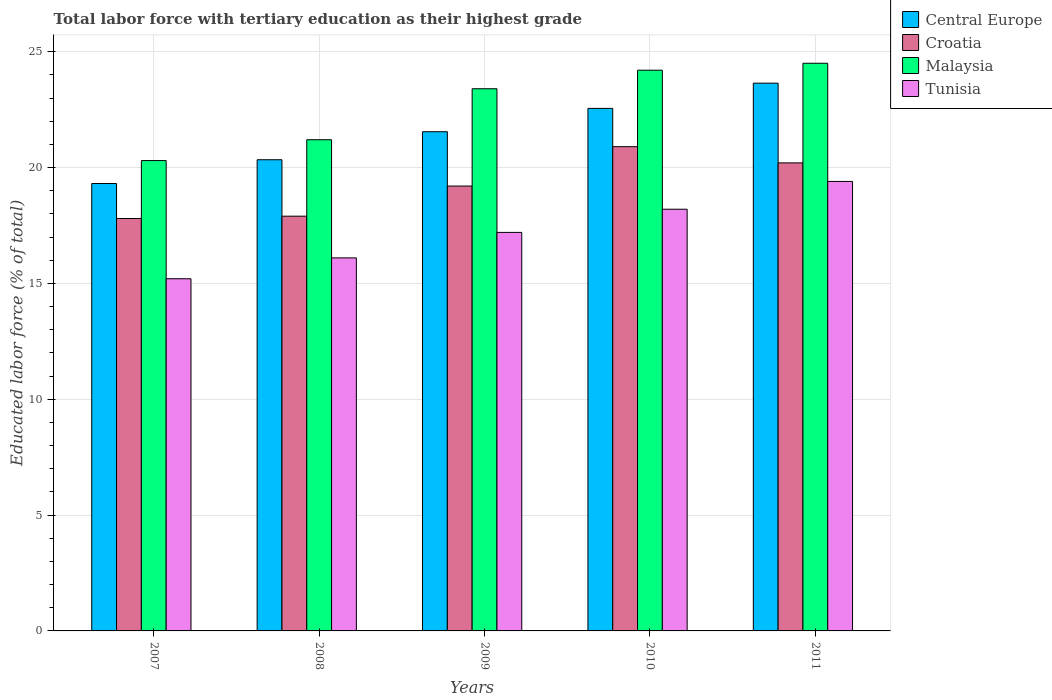How many different coloured bars are there?
Provide a succinct answer. 4. What is the label of the 1st group of bars from the left?
Provide a short and direct response. 2007. In how many cases, is the number of bars for a given year not equal to the number of legend labels?
Keep it short and to the point. 0. What is the percentage of male labor force with tertiary education in Central Europe in 2007?
Keep it short and to the point. 19.31. Across all years, what is the maximum percentage of male labor force with tertiary education in Tunisia?
Make the answer very short. 19.4. Across all years, what is the minimum percentage of male labor force with tertiary education in Croatia?
Give a very brief answer. 17.8. In which year was the percentage of male labor force with tertiary education in Malaysia maximum?
Your answer should be very brief. 2011. What is the total percentage of male labor force with tertiary education in Malaysia in the graph?
Make the answer very short. 113.6. What is the difference between the percentage of male labor force with tertiary education in Croatia in 2007 and that in 2008?
Your response must be concise. -0.1. What is the difference between the percentage of male labor force with tertiary education in Croatia in 2008 and the percentage of male labor force with tertiary education in Central Europe in 2011?
Make the answer very short. -5.74. What is the average percentage of male labor force with tertiary education in Tunisia per year?
Offer a very short reply. 17.22. In the year 2009, what is the difference between the percentage of male labor force with tertiary education in Tunisia and percentage of male labor force with tertiary education in Central Europe?
Keep it short and to the point. -4.35. What is the ratio of the percentage of male labor force with tertiary education in Tunisia in 2007 to that in 2010?
Your answer should be compact. 0.84. Is the difference between the percentage of male labor force with tertiary education in Tunisia in 2009 and 2011 greater than the difference between the percentage of male labor force with tertiary education in Central Europe in 2009 and 2011?
Ensure brevity in your answer.  No. What is the difference between the highest and the second highest percentage of male labor force with tertiary education in Croatia?
Ensure brevity in your answer.  0.7. What is the difference between the highest and the lowest percentage of male labor force with tertiary education in Central Europe?
Give a very brief answer. 4.33. In how many years, is the percentage of male labor force with tertiary education in Tunisia greater than the average percentage of male labor force with tertiary education in Tunisia taken over all years?
Keep it short and to the point. 2. What does the 3rd bar from the left in 2008 represents?
Provide a succinct answer. Malaysia. What does the 4th bar from the right in 2009 represents?
Your answer should be compact. Central Europe. How many bars are there?
Offer a terse response. 20. Are all the bars in the graph horizontal?
Offer a very short reply. No. Are the values on the major ticks of Y-axis written in scientific E-notation?
Provide a succinct answer. No. Where does the legend appear in the graph?
Provide a succinct answer. Top right. How many legend labels are there?
Offer a very short reply. 4. What is the title of the graph?
Make the answer very short. Total labor force with tertiary education as their highest grade. Does "Namibia" appear as one of the legend labels in the graph?
Your response must be concise. No. What is the label or title of the Y-axis?
Provide a short and direct response. Educated labor force (% of total). What is the Educated labor force (% of total) of Central Europe in 2007?
Give a very brief answer. 19.31. What is the Educated labor force (% of total) in Croatia in 2007?
Offer a terse response. 17.8. What is the Educated labor force (% of total) of Malaysia in 2007?
Give a very brief answer. 20.3. What is the Educated labor force (% of total) of Tunisia in 2007?
Make the answer very short. 15.2. What is the Educated labor force (% of total) of Central Europe in 2008?
Your answer should be compact. 20.34. What is the Educated labor force (% of total) of Croatia in 2008?
Give a very brief answer. 17.9. What is the Educated labor force (% of total) of Malaysia in 2008?
Keep it short and to the point. 21.2. What is the Educated labor force (% of total) of Tunisia in 2008?
Your answer should be very brief. 16.1. What is the Educated labor force (% of total) in Central Europe in 2009?
Offer a very short reply. 21.55. What is the Educated labor force (% of total) of Croatia in 2009?
Your response must be concise. 19.2. What is the Educated labor force (% of total) in Malaysia in 2009?
Your response must be concise. 23.4. What is the Educated labor force (% of total) of Tunisia in 2009?
Offer a terse response. 17.2. What is the Educated labor force (% of total) of Central Europe in 2010?
Provide a succinct answer. 22.55. What is the Educated labor force (% of total) of Croatia in 2010?
Make the answer very short. 20.9. What is the Educated labor force (% of total) of Malaysia in 2010?
Your response must be concise. 24.2. What is the Educated labor force (% of total) in Tunisia in 2010?
Your answer should be very brief. 18.2. What is the Educated labor force (% of total) in Central Europe in 2011?
Ensure brevity in your answer.  23.64. What is the Educated labor force (% of total) of Croatia in 2011?
Your answer should be very brief. 20.2. What is the Educated labor force (% of total) of Malaysia in 2011?
Make the answer very short. 24.5. What is the Educated labor force (% of total) of Tunisia in 2011?
Provide a short and direct response. 19.4. Across all years, what is the maximum Educated labor force (% of total) in Central Europe?
Offer a terse response. 23.64. Across all years, what is the maximum Educated labor force (% of total) in Croatia?
Ensure brevity in your answer.  20.9. Across all years, what is the maximum Educated labor force (% of total) of Tunisia?
Offer a terse response. 19.4. Across all years, what is the minimum Educated labor force (% of total) of Central Europe?
Keep it short and to the point. 19.31. Across all years, what is the minimum Educated labor force (% of total) of Croatia?
Make the answer very short. 17.8. Across all years, what is the minimum Educated labor force (% of total) of Malaysia?
Ensure brevity in your answer.  20.3. Across all years, what is the minimum Educated labor force (% of total) of Tunisia?
Ensure brevity in your answer.  15.2. What is the total Educated labor force (% of total) of Central Europe in the graph?
Offer a very short reply. 107.38. What is the total Educated labor force (% of total) in Croatia in the graph?
Your answer should be compact. 96. What is the total Educated labor force (% of total) of Malaysia in the graph?
Your answer should be very brief. 113.6. What is the total Educated labor force (% of total) in Tunisia in the graph?
Offer a very short reply. 86.1. What is the difference between the Educated labor force (% of total) in Central Europe in 2007 and that in 2008?
Ensure brevity in your answer.  -1.03. What is the difference between the Educated labor force (% of total) in Croatia in 2007 and that in 2008?
Provide a succinct answer. -0.1. What is the difference between the Educated labor force (% of total) in Tunisia in 2007 and that in 2008?
Give a very brief answer. -0.9. What is the difference between the Educated labor force (% of total) of Central Europe in 2007 and that in 2009?
Ensure brevity in your answer.  -2.23. What is the difference between the Educated labor force (% of total) of Tunisia in 2007 and that in 2009?
Give a very brief answer. -2. What is the difference between the Educated labor force (% of total) in Central Europe in 2007 and that in 2010?
Offer a terse response. -3.24. What is the difference between the Educated labor force (% of total) in Malaysia in 2007 and that in 2010?
Keep it short and to the point. -3.9. What is the difference between the Educated labor force (% of total) of Tunisia in 2007 and that in 2010?
Provide a succinct answer. -3. What is the difference between the Educated labor force (% of total) in Central Europe in 2007 and that in 2011?
Offer a terse response. -4.33. What is the difference between the Educated labor force (% of total) of Tunisia in 2007 and that in 2011?
Make the answer very short. -4.2. What is the difference between the Educated labor force (% of total) of Central Europe in 2008 and that in 2009?
Keep it short and to the point. -1.21. What is the difference between the Educated labor force (% of total) of Central Europe in 2008 and that in 2010?
Give a very brief answer. -2.22. What is the difference between the Educated labor force (% of total) in Croatia in 2008 and that in 2010?
Your answer should be compact. -3. What is the difference between the Educated labor force (% of total) of Malaysia in 2008 and that in 2010?
Offer a terse response. -3. What is the difference between the Educated labor force (% of total) in Tunisia in 2008 and that in 2010?
Provide a short and direct response. -2.1. What is the difference between the Educated labor force (% of total) of Central Europe in 2008 and that in 2011?
Keep it short and to the point. -3.3. What is the difference between the Educated labor force (% of total) in Malaysia in 2008 and that in 2011?
Offer a terse response. -3.3. What is the difference between the Educated labor force (% of total) of Central Europe in 2009 and that in 2010?
Offer a terse response. -1.01. What is the difference between the Educated labor force (% of total) of Croatia in 2009 and that in 2010?
Your answer should be very brief. -1.7. What is the difference between the Educated labor force (% of total) of Malaysia in 2009 and that in 2010?
Give a very brief answer. -0.8. What is the difference between the Educated labor force (% of total) in Central Europe in 2009 and that in 2011?
Your answer should be very brief. -2.1. What is the difference between the Educated labor force (% of total) in Croatia in 2009 and that in 2011?
Ensure brevity in your answer.  -1. What is the difference between the Educated labor force (% of total) in Central Europe in 2010 and that in 2011?
Make the answer very short. -1.09. What is the difference between the Educated labor force (% of total) in Croatia in 2010 and that in 2011?
Your response must be concise. 0.7. What is the difference between the Educated labor force (% of total) in Malaysia in 2010 and that in 2011?
Ensure brevity in your answer.  -0.3. What is the difference between the Educated labor force (% of total) in Central Europe in 2007 and the Educated labor force (% of total) in Croatia in 2008?
Ensure brevity in your answer.  1.41. What is the difference between the Educated labor force (% of total) in Central Europe in 2007 and the Educated labor force (% of total) in Malaysia in 2008?
Your response must be concise. -1.89. What is the difference between the Educated labor force (% of total) in Central Europe in 2007 and the Educated labor force (% of total) in Tunisia in 2008?
Offer a terse response. 3.21. What is the difference between the Educated labor force (% of total) in Croatia in 2007 and the Educated labor force (% of total) in Tunisia in 2008?
Give a very brief answer. 1.7. What is the difference between the Educated labor force (% of total) of Central Europe in 2007 and the Educated labor force (% of total) of Croatia in 2009?
Provide a succinct answer. 0.11. What is the difference between the Educated labor force (% of total) of Central Europe in 2007 and the Educated labor force (% of total) of Malaysia in 2009?
Provide a short and direct response. -4.09. What is the difference between the Educated labor force (% of total) in Central Europe in 2007 and the Educated labor force (% of total) in Tunisia in 2009?
Your answer should be compact. 2.11. What is the difference between the Educated labor force (% of total) of Croatia in 2007 and the Educated labor force (% of total) of Malaysia in 2009?
Offer a very short reply. -5.6. What is the difference between the Educated labor force (% of total) of Croatia in 2007 and the Educated labor force (% of total) of Tunisia in 2009?
Your answer should be very brief. 0.6. What is the difference between the Educated labor force (% of total) of Malaysia in 2007 and the Educated labor force (% of total) of Tunisia in 2009?
Keep it short and to the point. 3.1. What is the difference between the Educated labor force (% of total) in Central Europe in 2007 and the Educated labor force (% of total) in Croatia in 2010?
Make the answer very short. -1.59. What is the difference between the Educated labor force (% of total) in Central Europe in 2007 and the Educated labor force (% of total) in Malaysia in 2010?
Provide a short and direct response. -4.89. What is the difference between the Educated labor force (% of total) in Central Europe in 2007 and the Educated labor force (% of total) in Tunisia in 2010?
Your response must be concise. 1.11. What is the difference between the Educated labor force (% of total) in Croatia in 2007 and the Educated labor force (% of total) in Malaysia in 2010?
Provide a short and direct response. -6.4. What is the difference between the Educated labor force (% of total) of Croatia in 2007 and the Educated labor force (% of total) of Tunisia in 2010?
Offer a terse response. -0.4. What is the difference between the Educated labor force (% of total) of Central Europe in 2007 and the Educated labor force (% of total) of Croatia in 2011?
Provide a short and direct response. -0.89. What is the difference between the Educated labor force (% of total) in Central Europe in 2007 and the Educated labor force (% of total) in Malaysia in 2011?
Give a very brief answer. -5.19. What is the difference between the Educated labor force (% of total) of Central Europe in 2007 and the Educated labor force (% of total) of Tunisia in 2011?
Your answer should be compact. -0.09. What is the difference between the Educated labor force (% of total) of Croatia in 2007 and the Educated labor force (% of total) of Malaysia in 2011?
Offer a very short reply. -6.7. What is the difference between the Educated labor force (% of total) of Croatia in 2007 and the Educated labor force (% of total) of Tunisia in 2011?
Give a very brief answer. -1.6. What is the difference between the Educated labor force (% of total) in Central Europe in 2008 and the Educated labor force (% of total) in Croatia in 2009?
Keep it short and to the point. 1.14. What is the difference between the Educated labor force (% of total) of Central Europe in 2008 and the Educated labor force (% of total) of Malaysia in 2009?
Provide a short and direct response. -3.06. What is the difference between the Educated labor force (% of total) in Central Europe in 2008 and the Educated labor force (% of total) in Tunisia in 2009?
Offer a very short reply. 3.14. What is the difference between the Educated labor force (% of total) of Croatia in 2008 and the Educated labor force (% of total) of Malaysia in 2009?
Make the answer very short. -5.5. What is the difference between the Educated labor force (% of total) in Central Europe in 2008 and the Educated labor force (% of total) in Croatia in 2010?
Make the answer very short. -0.56. What is the difference between the Educated labor force (% of total) in Central Europe in 2008 and the Educated labor force (% of total) in Malaysia in 2010?
Give a very brief answer. -3.86. What is the difference between the Educated labor force (% of total) in Central Europe in 2008 and the Educated labor force (% of total) in Tunisia in 2010?
Offer a very short reply. 2.14. What is the difference between the Educated labor force (% of total) in Croatia in 2008 and the Educated labor force (% of total) in Malaysia in 2010?
Keep it short and to the point. -6.3. What is the difference between the Educated labor force (% of total) in Central Europe in 2008 and the Educated labor force (% of total) in Croatia in 2011?
Your answer should be very brief. 0.14. What is the difference between the Educated labor force (% of total) in Central Europe in 2008 and the Educated labor force (% of total) in Malaysia in 2011?
Make the answer very short. -4.16. What is the difference between the Educated labor force (% of total) in Central Europe in 2008 and the Educated labor force (% of total) in Tunisia in 2011?
Provide a succinct answer. 0.94. What is the difference between the Educated labor force (% of total) of Croatia in 2008 and the Educated labor force (% of total) of Malaysia in 2011?
Offer a terse response. -6.6. What is the difference between the Educated labor force (% of total) of Central Europe in 2009 and the Educated labor force (% of total) of Croatia in 2010?
Keep it short and to the point. 0.65. What is the difference between the Educated labor force (% of total) of Central Europe in 2009 and the Educated labor force (% of total) of Malaysia in 2010?
Give a very brief answer. -2.65. What is the difference between the Educated labor force (% of total) in Central Europe in 2009 and the Educated labor force (% of total) in Tunisia in 2010?
Your answer should be compact. 3.35. What is the difference between the Educated labor force (% of total) in Central Europe in 2009 and the Educated labor force (% of total) in Croatia in 2011?
Your answer should be very brief. 1.35. What is the difference between the Educated labor force (% of total) in Central Europe in 2009 and the Educated labor force (% of total) in Malaysia in 2011?
Provide a succinct answer. -2.95. What is the difference between the Educated labor force (% of total) in Central Europe in 2009 and the Educated labor force (% of total) in Tunisia in 2011?
Offer a very short reply. 2.15. What is the difference between the Educated labor force (% of total) in Croatia in 2009 and the Educated labor force (% of total) in Tunisia in 2011?
Make the answer very short. -0.2. What is the difference between the Educated labor force (% of total) in Malaysia in 2009 and the Educated labor force (% of total) in Tunisia in 2011?
Ensure brevity in your answer.  4. What is the difference between the Educated labor force (% of total) of Central Europe in 2010 and the Educated labor force (% of total) of Croatia in 2011?
Give a very brief answer. 2.35. What is the difference between the Educated labor force (% of total) of Central Europe in 2010 and the Educated labor force (% of total) of Malaysia in 2011?
Give a very brief answer. -1.95. What is the difference between the Educated labor force (% of total) of Central Europe in 2010 and the Educated labor force (% of total) of Tunisia in 2011?
Your answer should be very brief. 3.15. What is the difference between the Educated labor force (% of total) in Croatia in 2010 and the Educated labor force (% of total) in Malaysia in 2011?
Your answer should be compact. -3.6. What is the average Educated labor force (% of total) in Central Europe per year?
Provide a succinct answer. 21.48. What is the average Educated labor force (% of total) in Malaysia per year?
Your answer should be compact. 22.72. What is the average Educated labor force (% of total) of Tunisia per year?
Provide a succinct answer. 17.22. In the year 2007, what is the difference between the Educated labor force (% of total) of Central Europe and Educated labor force (% of total) of Croatia?
Provide a succinct answer. 1.51. In the year 2007, what is the difference between the Educated labor force (% of total) in Central Europe and Educated labor force (% of total) in Malaysia?
Offer a very short reply. -0.99. In the year 2007, what is the difference between the Educated labor force (% of total) of Central Europe and Educated labor force (% of total) of Tunisia?
Give a very brief answer. 4.11. In the year 2007, what is the difference between the Educated labor force (% of total) of Croatia and Educated labor force (% of total) of Malaysia?
Your response must be concise. -2.5. In the year 2007, what is the difference between the Educated labor force (% of total) in Croatia and Educated labor force (% of total) in Tunisia?
Make the answer very short. 2.6. In the year 2008, what is the difference between the Educated labor force (% of total) of Central Europe and Educated labor force (% of total) of Croatia?
Offer a very short reply. 2.44. In the year 2008, what is the difference between the Educated labor force (% of total) of Central Europe and Educated labor force (% of total) of Malaysia?
Offer a very short reply. -0.86. In the year 2008, what is the difference between the Educated labor force (% of total) in Central Europe and Educated labor force (% of total) in Tunisia?
Keep it short and to the point. 4.24. In the year 2008, what is the difference between the Educated labor force (% of total) of Croatia and Educated labor force (% of total) of Malaysia?
Your answer should be compact. -3.3. In the year 2008, what is the difference between the Educated labor force (% of total) in Croatia and Educated labor force (% of total) in Tunisia?
Provide a short and direct response. 1.8. In the year 2008, what is the difference between the Educated labor force (% of total) in Malaysia and Educated labor force (% of total) in Tunisia?
Provide a short and direct response. 5.1. In the year 2009, what is the difference between the Educated labor force (% of total) in Central Europe and Educated labor force (% of total) in Croatia?
Ensure brevity in your answer.  2.35. In the year 2009, what is the difference between the Educated labor force (% of total) in Central Europe and Educated labor force (% of total) in Malaysia?
Provide a succinct answer. -1.85. In the year 2009, what is the difference between the Educated labor force (% of total) in Central Europe and Educated labor force (% of total) in Tunisia?
Keep it short and to the point. 4.35. In the year 2009, what is the difference between the Educated labor force (% of total) in Croatia and Educated labor force (% of total) in Malaysia?
Your answer should be very brief. -4.2. In the year 2010, what is the difference between the Educated labor force (% of total) in Central Europe and Educated labor force (% of total) in Croatia?
Give a very brief answer. 1.65. In the year 2010, what is the difference between the Educated labor force (% of total) of Central Europe and Educated labor force (% of total) of Malaysia?
Ensure brevity in your answer.  -1.65. In the year 2010, what is the difference between the Educated labor force (% of total) in Central Europe and Educated labor force (% of total) in Tunisia?
Offer a very short reply. 4.35. In the year 2010, what is the difference between the Educated labor force (% of total) in Croatia and Educated labor force (% of total) in Malaysia?
Offer a very short reply. -3.3. In the year 2011, what is the difference between the Educated labor force (% of total) in Central Europe and Educated labor force (% of total) in Croatia?
Your response must be concise. 3.44. In the year 2011, what is the difference between the Educated labor force (% of total) of Central Europe and Educated labor force (% of total) of Malaysia?
Offer a terse response. -0.86. In the year 2011, what is the difference between the Educated labor force (% of total) in Central Europe and Educated labor force (% of total) in Tunisia?
Offer a terse response. 4.24. In the year 2011, what is the difference between the Educated labor force (% of total) in Croatia and Educated labor force (% of total) in Malaysia?
Your answer should be very brief. -4.3. In the year 2011, what is the difference between the Educated labor force (% of total) in Croatia and Educated labor force (% of total) in Tunisia?
Your answer should be very brief. 0.8. What is the ratio of the Educated labor force (% of total) of Central Europe in 2007 to that in 2008?
Your answer should be very brief. 0.95. What is the ratio of the Educated labor force (% of total) in Croatia in 2007 to that in 2008?
Your answer should be compact. 0.99. What is the ratio of the Educated labor force (% of total) of Malaysia in 2007 to that in 2008?
Offer a very short reply. 0.96. What is the ratio of the Educated labor force (% of total) of Tunisia in 2007 to that in 2008?
Your answer should be compact. 0.94. What is the ratio of the Educated labor force (% of total) in Central Europe in 2007 to that in 2009?
Offer a terse response. 0.9. What is the ratio of the Educated labor force (% of total) of Croatia in 2007 to that in 2009?
Your answer should be compact. 0.93. What is the ratio of the Educated labor force (% of total) in Malaysia in 2007 to that in 2009?
Offer a terse response. 0.87. What is the ratio of the Educated labor force (% of total) of Tunisia in 2007 to that in 2009?
Provide a short and direct response. 0.88. What is the ratio of the Educated labor force (% of total) in Central Europe in 2007 to that in 2010?
Give a very brief answer. 0.86. What is the ratio of the Educated labor force (% of total) in Croatia in 2007 to that in 2010?
Your answer should be very brief. 0.85. What is the ratio of the Educated labor force (% of total) in Malaysia in 2007 to that in 2010?
Your response must be concise. 0.84. What is the ratio of the Educated labor force (% of total) of Tunisia in 2007 to that in 2010?
Offer a very short reply. 0.84. What is the ratio of the Educated labor force (% of total) of Central Europe in 2007 to that in 2011?
Your answer should be very brief. 0.82. What is the ratio of the Educated labor force (% of total) of Croatia in 2007 to that in 2011?
Ensure brevity in your answer.  0.88. What is the ratio of the Educated labor force (% of total) in Malaysia in 2007 to that in 2011?
Give a very brief answer. 0.83. What is the ratio of the Educated labor force (% of total) of Tunisia in 2007 to that in 2011?
Provide a short and direct response. 0.78. What is the ratio of the Educated labor force (% of total) in Central Europe in 2008 to that in 2009?
Ensure brevity in your answer.  0.94. What is the ratio of the Educated labor force (% of total) in Croatia in 2008 to that in 2009?
Ensure brevity in your answer.  0.93. What is the ratio of the Educated labor force (% of total) in Malaysia in 2008 to that in 2009?
Your response must be concise. 0.91. What is the ratio of the Educated labor force (% of total) in Tunisia in 2008 to that in 2009?
Provide a short and direct response. 0.94. What is the ratio of the Educated labor force (% of total) of Central Europe in 2008 to that in 2010?
Your answer should be very brief. 0.9. What is the ratio of the Educated labor force (% of total) in Croatia in 2008 to that in 2010?
Your answer should be very brief. 0.86. What is the ratio of the Educated labor force (% of total) of Malaysia in 2008 to that in 2010?
Ensure brevity in your answer.  0.88. What is the ratio of the Educated labor force (% of total) of Tunisia in 2008 to that in 2010?
Keep it short and to the point. 0.88. What is the ratio of the Educated labor force (% of total) of Central Europe in 2008 to that in 2011?
Give a very brief answer. 0.86. What is the ratio of the Educated labor force (% of total) of Croatia in 2008 to that in 2011?
Offer a terse response. 0.89. What is the ratio of the Educated labor force (% of total) in Malaysia in 2008 to that in 2011?
Provide a short and direct response. 0.87. What is the ratio of the Educated labor force (% of total) of Tunisia in 2008 to that in 2011?
Make the answer very short. 0.83. What is the ratio of the Educated labor force (% of total) in Central Europe in 2009 to that in 2010?
Ensure brevity in your answer.  0.96. What is the ratio of the Educated labor force (% of total) in Croatia in 2009 to that in 2010?
Offer a very short reply. 0.92. What is the ratio of the Educated labor force (% of total) of Malaysia in 2009 to that in 2010?
Offer a very short reply. 0.97. What is the ratio of the Educated labor force (% of total) of Tunisia in 2009 to that in 2010?
Provide a succinct answer. 0.95. What is the ratio of the Educated labor force (% of total) of Central Europe in 2009 to that in 2011?
Your answer should be very brief. 0.91. What is the ratio of the Educated labor force (% of total) of Croatia in 2009 to that in 2011?
Offer a terse response. 0.95. What is the ratio of the Educated labor force (% of total) of Malaysia in 2009 to that in 2011?
Offer a terse response. 0.96. What is the ratio of the Educated labor force (% of total) of Tunisia in 2009 to that in 2011?
Ensure brevity in your answer.  0.89. What is the ratio of the Educated labor force (% of total) of Central Europe in 2010 to that in 2011?
Give a very brief answer. 0.95. What is the ratio of the Educated labor force (% of total) of Croatia in 2010 to that in 2011?
Ensure brevity in your answer.  1.03. What is the ratio of the Educated labor force (% of total) of Malaysia in 2010 to that in 2011?
Offer a very short reply. 0.99. What is the ratio of the Educated labor force (% of total) in Tunisia in 2010 to that in 2011?
Your response must be concise. 0.94. What is the difference between the highest and the second highest Educated labor force (% of total) in Central Europe?
Your answer should be compact. 1.09. What is the difference between the highest and the second highest Educated labor force (% of total) of Croatia?
Give a very brief answer. 0.7. What is the difference between the highest and the second highest Educated labor force (% of total) in Tunisia?
Offer a terse response. 1.2. What is the difference between the highest and the lowest Educated labor force (% of total) in Central Europe?
Your answer should be compact. 4.33. What is the difference between the highest and the lowest Educated labor force (% of total) of Croatia?
Provide a short and direct response. 3.1. What is the difference between the highest and the lowest Educated labor force (% of total) of Malaysia?
Provide a succinct answer. 4.2. 